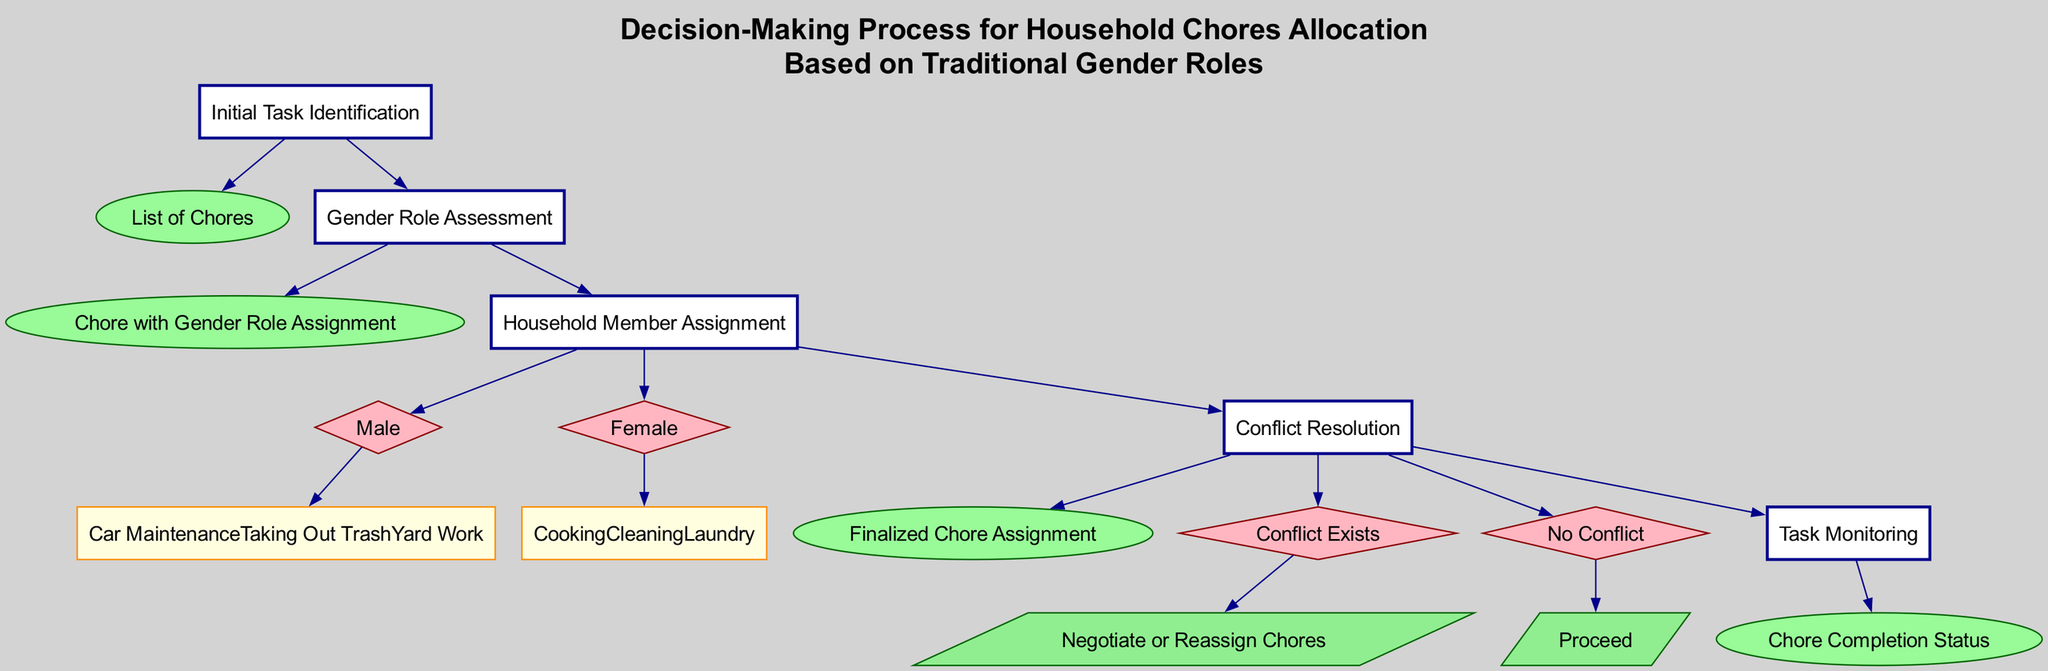what is the first step in the decision-making process? The first step is "Initial Task Identification," which is shown as the starting node in the diagram. It identifies the household chores that need to be accomplished.
Answer: Initial Task Identification how many decision criteria are present in the "Conflict Resolution" step? In the "Conflict Resolution" step, there are two decision criteria illustrated: "Conflict Exists" and "No Conflict." These are depicted as diamond-shaped nodes branching from the main step.
Answer: 2 which household member is assigned "Cooking"? According to the "Household Member Assignment" step based on gender role assessment, "Cooking" is assigned to the female household member. This is represented under the female criteria.
Answer: Female what is the output of the "Task Monitoring" step? The output of the "Task Monitoring" step is indicated as "Chore Completion Status," which is shown in an oval node connected to that step in the diagram.
Answer: Chore Completion Status if a conflict exists during the assignment, what is the resolution advised? If a conflict exists according to the "Conflict Resolution" step, the advised resolution is "Negotiate or Reassign Chores," which is detailed in the corresponding diamond node in the diagram.
Answer: Negotiate or Reassign Chores which chores are assigned to males according to the "Household Member Assignment"? The chores assigned to males include "Car Maintenance," "Taking Out Trash," and "Yard Work," listed under the male criteria in the diagram.
Answer: Car Maintenance, Taking Out Trash, Yard Work what follows after the "Gender Role Assessment" step? After the "Gender Role Assessment" step, the next step is "Household Member Assignment," which is connected by a directed edge in the flow chart.
Answer: Household Member Assignment what does the step "Initial Task Identification" output? The "Initial Task Identification" step outputs a "List of Chores," clearly indicated in the diagram as the result of that step.
Answer: List of Chores what type of shape represents the "Decision Criteria" nodes? The "Decision Criteria" nodes are represented by diamond shapes, as commonly used in flow charts to indicate a decision point or criteria to evaluate.
Answer: Diamond 